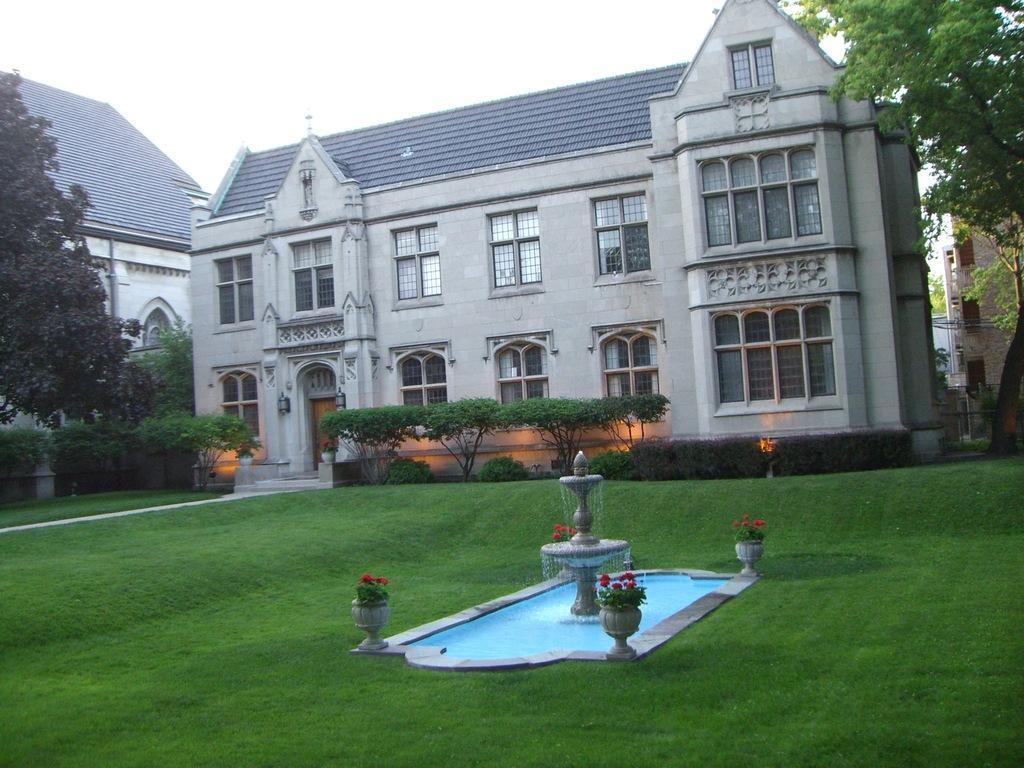What is located in the center of the image? There are buildings in the center of the image. What type of vegetation can be seen in the image? There are trees, plants, and grass visible in the image. What is a feature in the image that provides water? There is a fountain in the image. What type of flora is present in the image? There are flowers in the image. What is visible at the top of the image? The sky is visible at the top of the image. What is the income of the bee buzzing around the flowers in the image? There is no bee present in the image, so it is not possible to determine its income. What type of tin can be seen in the image? There is no tin present in the image. 